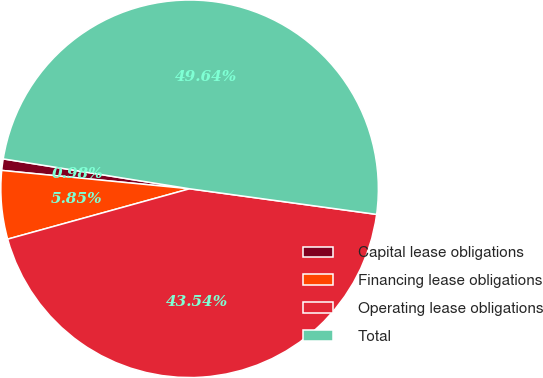<chart> <loc_0><loc_0><loc_500><loc_500><pie_chart><fcel>Capital lease obligations<fcel>Financing lease obligations<fcel>Operating lease obligations<fcel>Total<nl><fcel>0.98%<fcel>5.85%<fcel>43.54%<fcel>49.64%<nl></chart> 